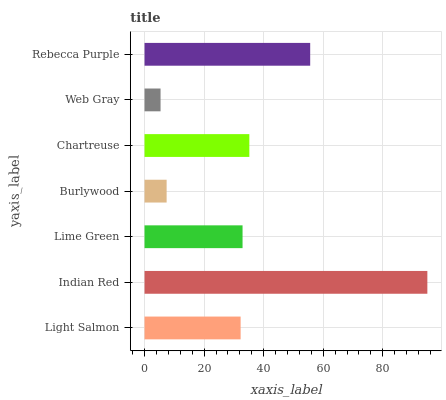Is Web Gray the minimum?
Answer yes or no. Yes. Is Indian Red the maximum?
Answer yes or no. Yes. Is Lime Green the minimum?
Answer yes or no. No. Is Lime Green the maximum?
Answer yes or no. No. Is Indian Red greater than Lime Green?
Answer yes or no. Yes. Is Lime Green less than Indian Red?
Answer yes or no. Yes. Is Lime Green greater than Indian Red?
Answer yes or no. No. Is Indian Red less than Lime Green?
Answer yes or no. No. Is Lime Green the high median?
Answer yes or no. Yes. Is Lime Green the low median?
Answer yes or no. Yes. Is Light Salmon the high median?
Answer yes or no. No. Is Chartreuse the low median?
Answer yes or no. No. 